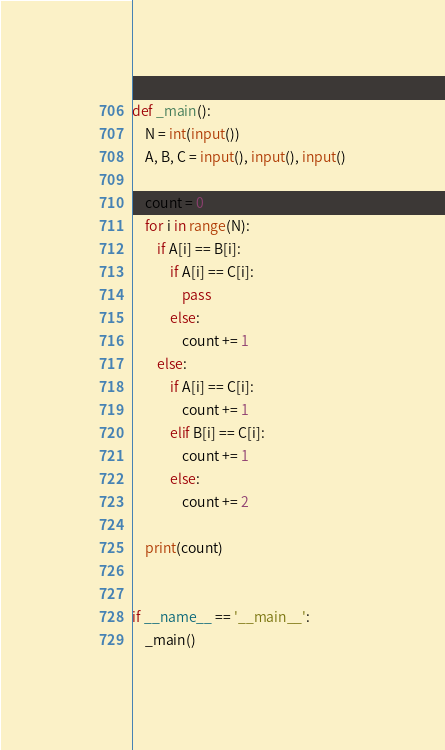<code> <loc_0><loc_0><loc_500><loc_500><_Python_>

def _main():
    N = int(input())
    A, B, C = input(), input(), input()

    count = 0
    for i in range(N):
        if A[i] == B[i]:
            if A[i] == C[i]:
                pass
            else:
                count += 1
        else:
            if A[i] == C[i]:
                count += 1
            elif B[i] == C[i]:
                count += 1
            else:
                count += 2

    print(count)


if __name__ == '__main__':
    _main()
</code> 